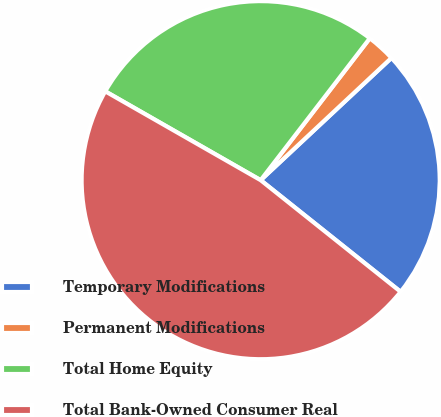<chart> <loc_0><loc_0><loc_500><loc_500><pie_chart><fcel>Temporary Modifications<fcel>Permanent Modifications<fcel>Total Home Equity<fcel>Total Bank-Owned Consumer Real<nl><fcel>22.68%<fcel>2.6%<fcel>27.17%<fcel>47.55%<nl></chart> 